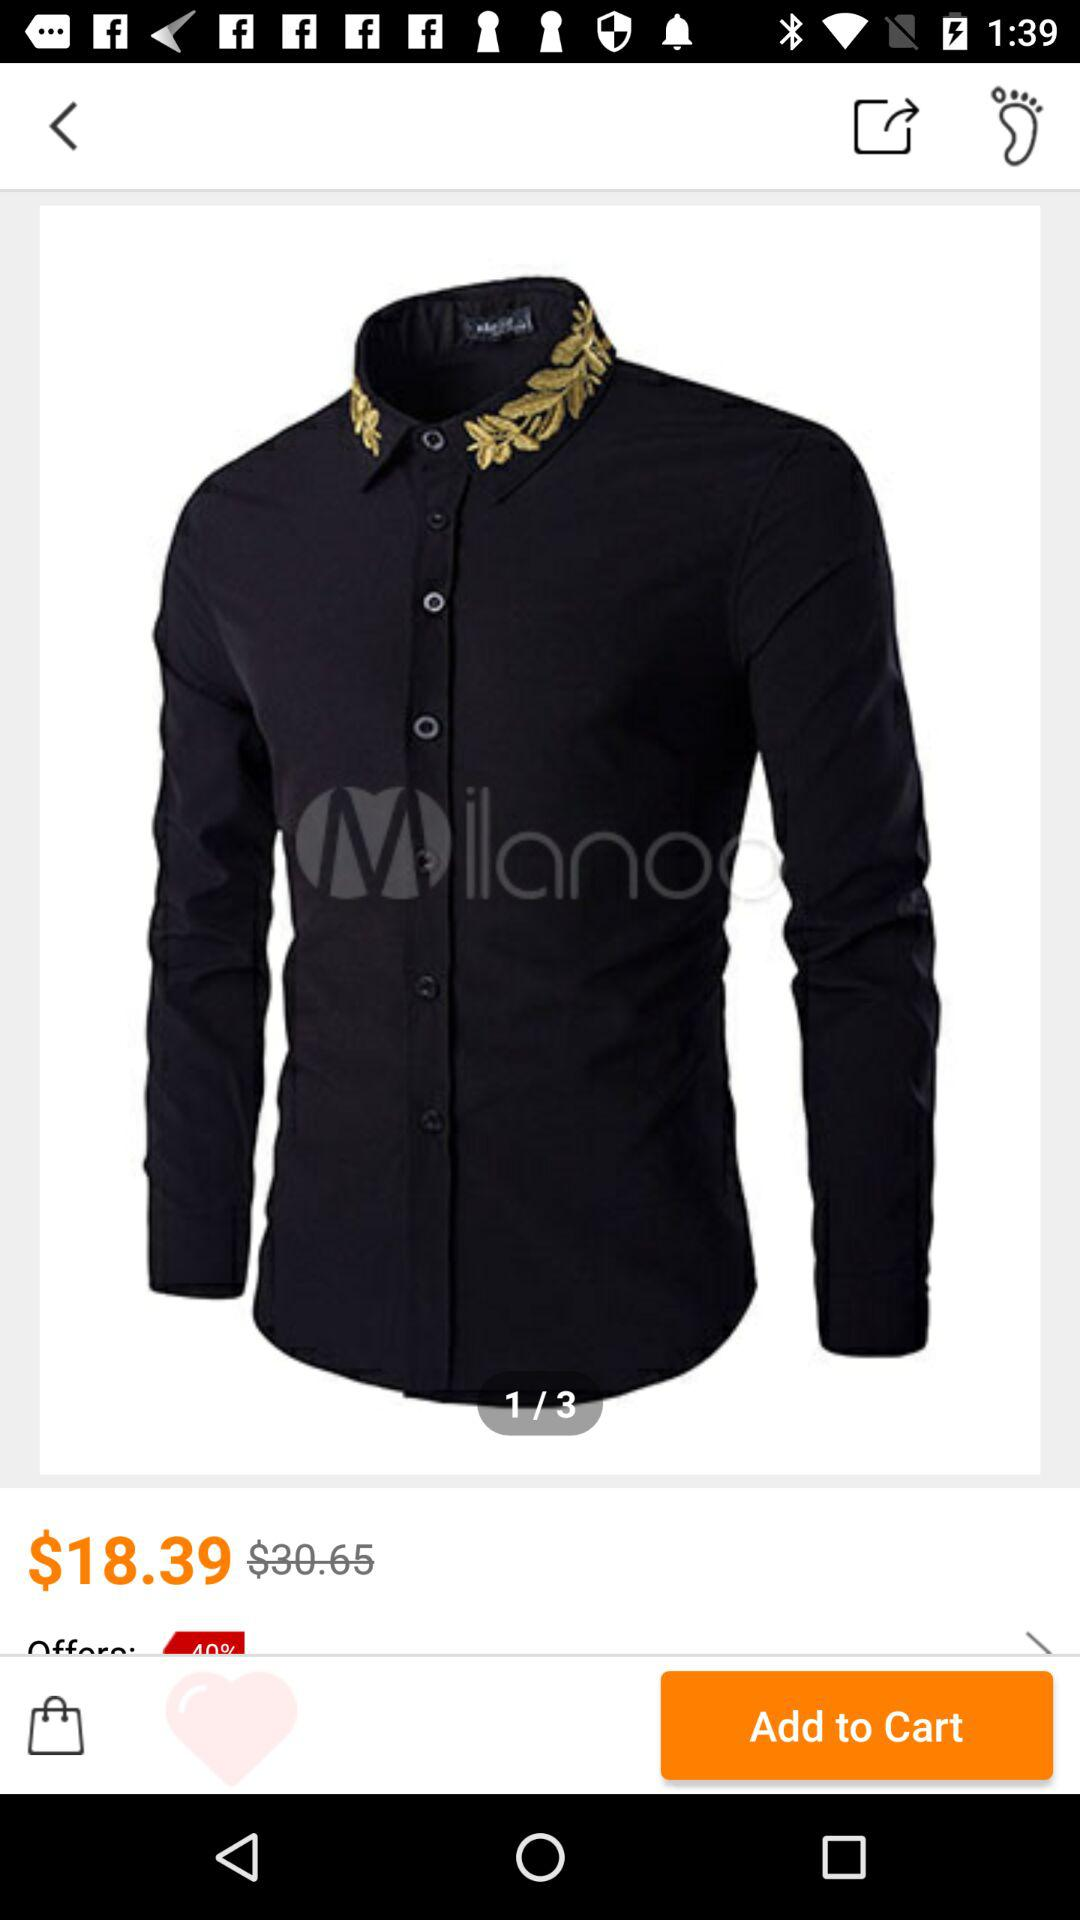What is the price after the discount? The discounted price is $18.39. 